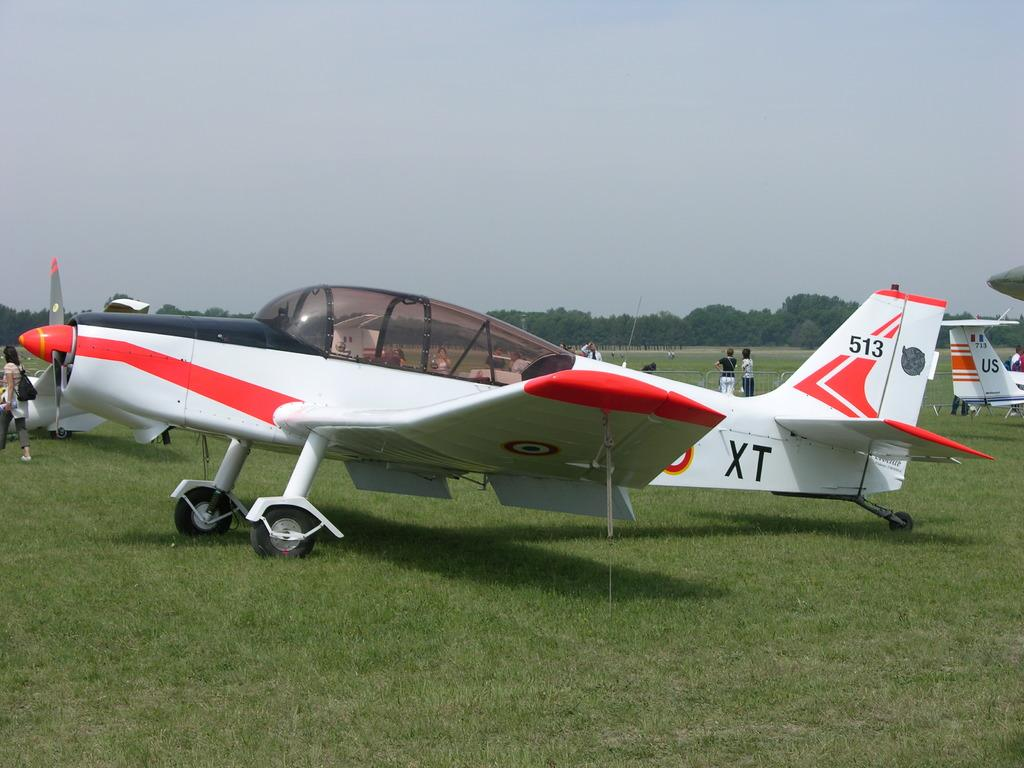<image>
Provide a brief description of the given image. A small craft airplane bearing the number 513 on the tail and the letters XT on the fuselage is parked on an airfield. 